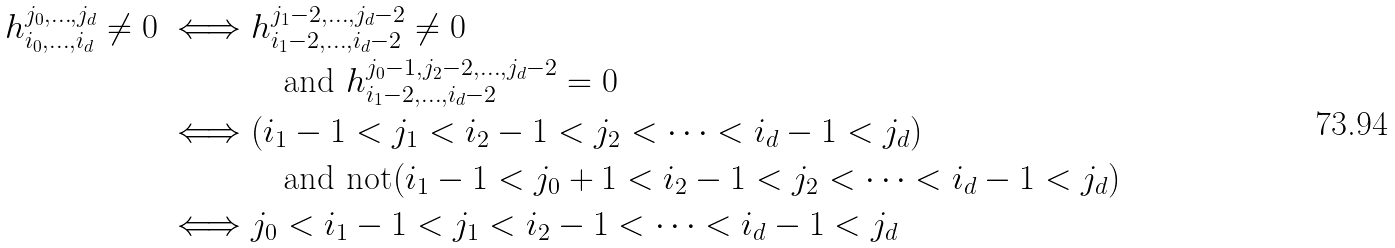Convert formula to latex. <formula><loc_0><loc_0><loc_500><loc_500>h _ { i _ { 0 } , \dots , i _ { d } } ^ { j _ { 0 } , \dots , j _ { d } } \neq 0 \iff & h _ { i _ { 1 } - 2 , \dots , i _ { d } - 2 } ^ { j _ { 1 } - 2 , \dots , j _ { d } - 2 } \neq 0 \\ & \quad \text {and } h _ { i _ { 1 } - 2 , \dots , i _ { d } - 2 } ^ { j _ { 0 } - 1 , j _ { 2 } - 2 , \dots , j _ { d } - 2 } = 0 \\ \iff & ( i _ { 1 } - 1 < j _ { 1 } < i _ { 2 } - 1 < j _ { 2 } < \cdots < i _ { d } - 1 < j _ { d } ) \\ & \quad \text {and not} ( i _ { 1 } - 1 < j _ { 0 } + 1 < i _ { 2 } - 1 < j _ { 2 } < \cdots < i _ { d } - 1 < j _ { d } ) \\ \iff & j _ { 0 } < i _ { 1 } - 1 < j _ { 1 } < i _ { 2 } - 1 < \cdots < i _ { d } - 1 < j _ { d }</formula> 